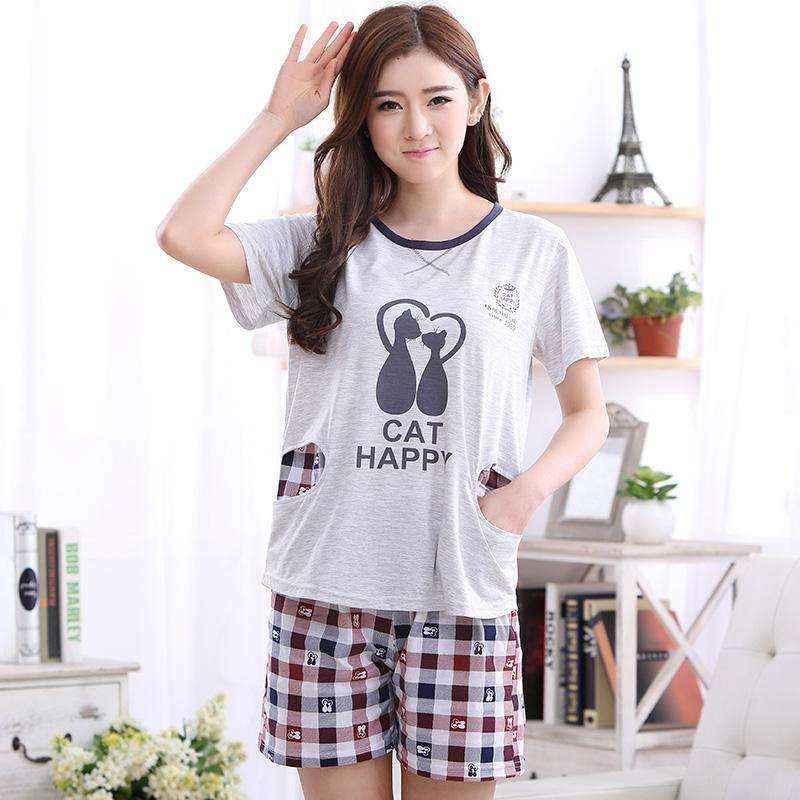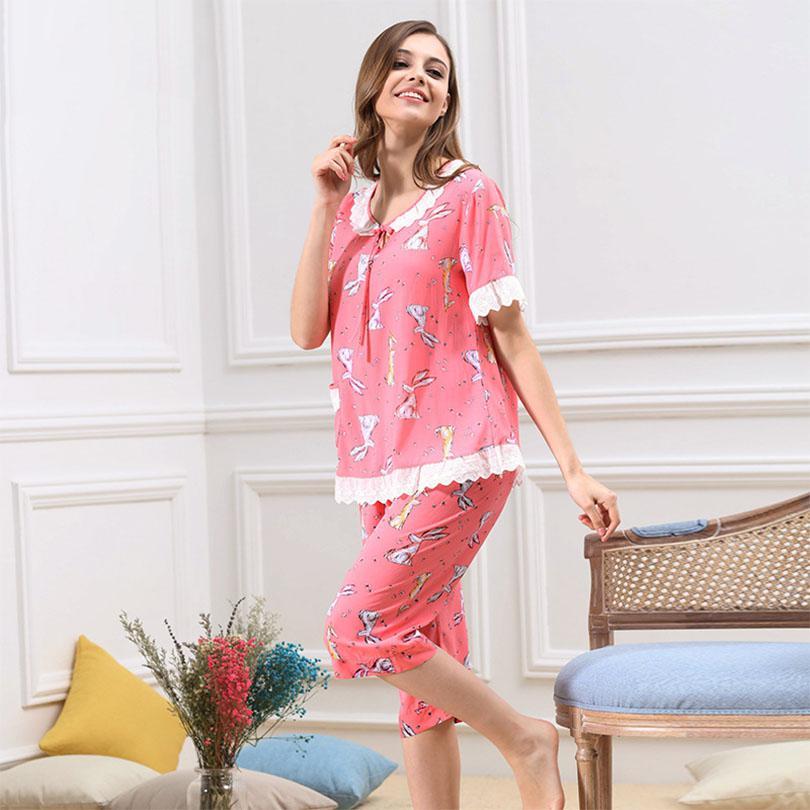The first image is the image on the left, the second image is the image on the right. Considering the images on both sides, is "The right image contains one person that is wearing predominately blue sleep wear." valid? Answer yes or no. No. The first image is the image on the left, the second image is the image on the right. For the images shown, is this caption "All images include a human model wearing a pajama set featuring plaid bottoms, and one model in matching blue top and bottom is in front of a row of pillows." true? Answer yes or no. No. 